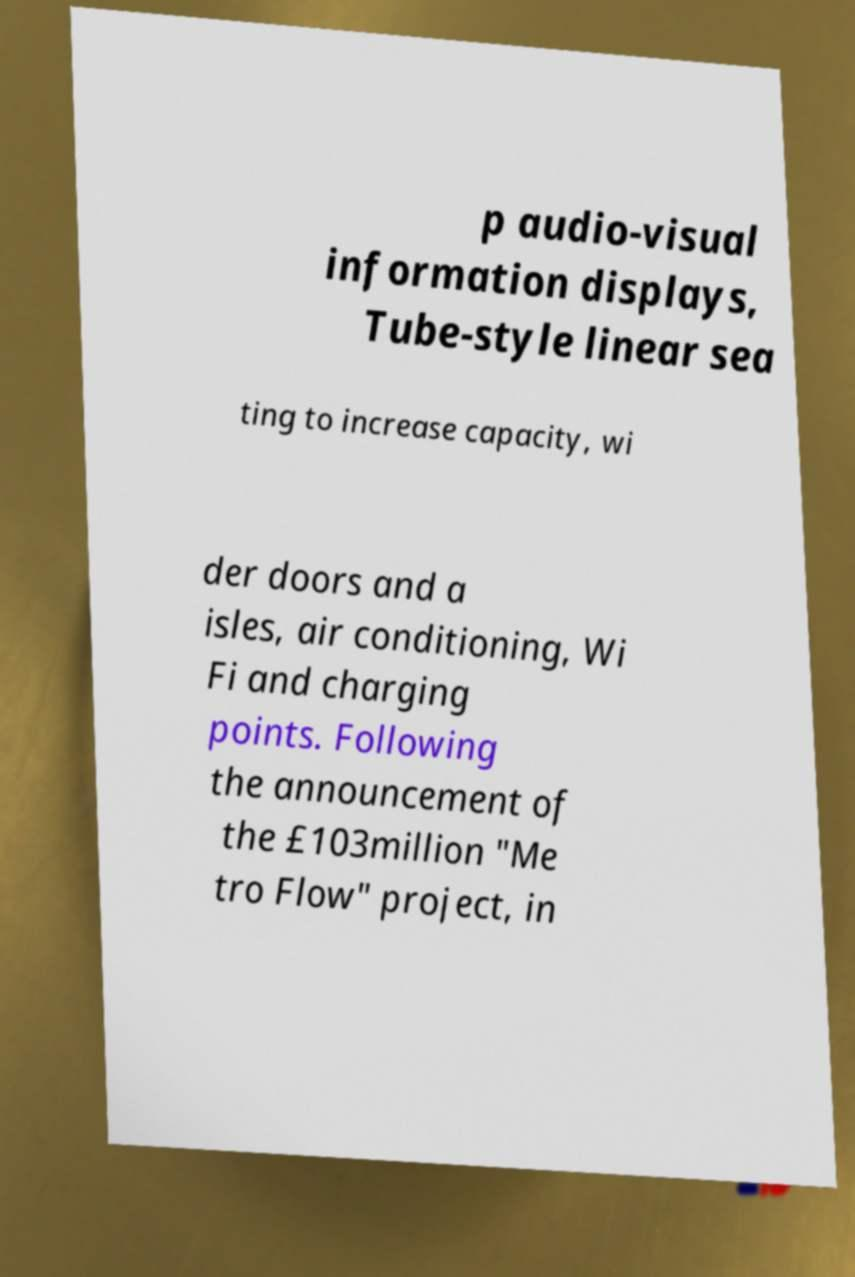Please identify and transcribe the text found in this image. p audio-visual information displays, Tube-style linear sea ting to increase capacity, wi der doors and a isles, air conditioning, Wi Fi and charging points. Following the announcement of the £103million "Me tro Flow" project, in 